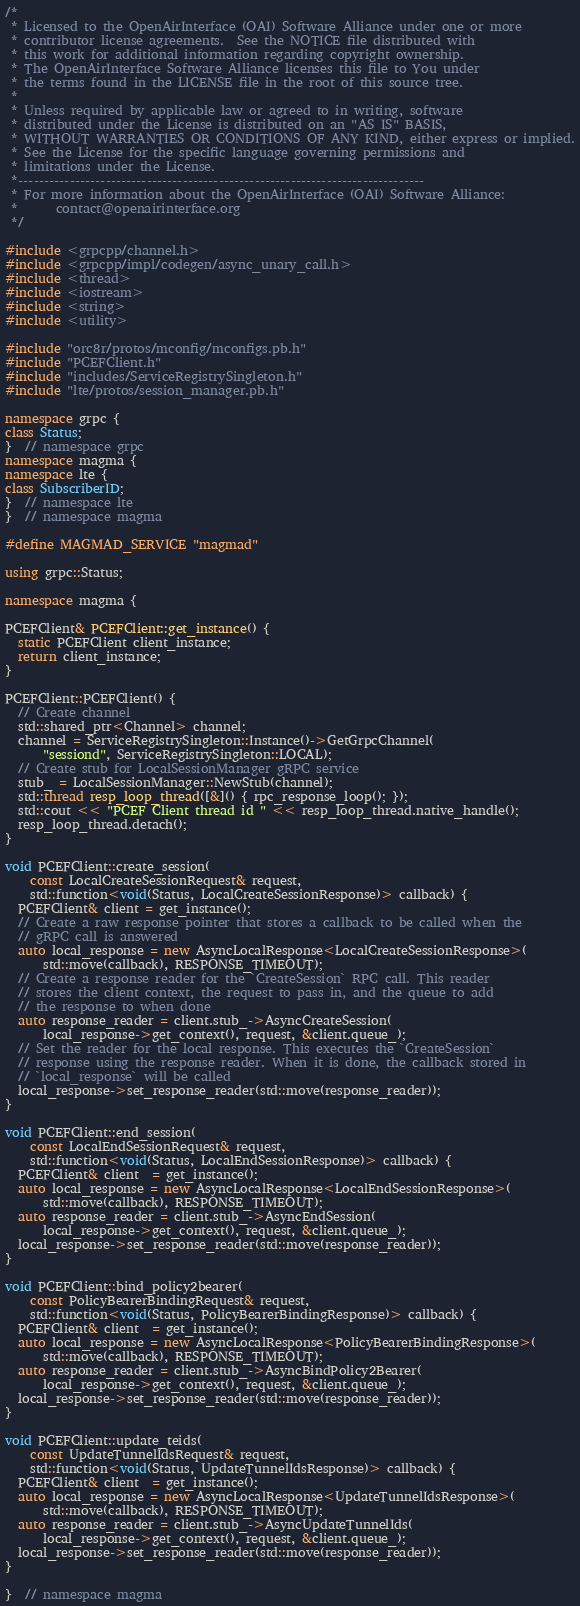<code> <loc_0><loc_0><loc_500><loc_500><_C++_>/*
 * Licensed to the OpenAirInterface (OAI) Software Alliance under one or more
 * contributor license agreements.  See the NOTICE file distributed with
 * this work for additional information regarding copyright ownership.
 * The OpenAirInterface Software Alliance licenses this file to You under
 * the terms found in the LICENSE file in the root of this source tree.
 *
 * Unless required by applicable law or agreed to in writing, software
 * distributed under the License is distributed on an "AS IS" BASIS,
 * WITHOUT WARRANTIES OR CONDITIONS OF ANY KIND, either express or implied.
 * See the License for the specific language governing permissions and
 * limitations under the License.
 *-------------------------------------------------------------------------------
 * For more information about the OpenAirInterface (OAI) Software Alliance:
 *      contact@openairinterface.org
 */

#include <grpcpp/channel.h>
#include <grpcpp/impl/codegen/async_unary_call.h>
#include <thread>
#include <iostream>
#include <string>
#include <utility>

#include "orc8r/protos/mconfig/mconfigs.pb.h"
#include "PCEFClient.h"
#include "includes/ServiceRegistrySingleton.h"
#include "lte/protos/session_manager.pb.h"

namespace grpc {
class Status;
}  // namespace grpc
namespace magma {
namespace lte {
class SubscriberID;
}  // namespace lte
}  // namespace magma

#define MAGMAD_SERVICE "magmad"

using grpc::Status;

namespace magma {

PCEFClient& PCEFClient::get_instance() {
  static PCEFClient client_instance;
  return client_instance;
}

PCEFClient::PCEFClient() {
  // Create channel
  std::shared_ptr<Channel> channel;
  channel = ServiceRegistrySingleton::Instance()->GetGrpcChannel(
      "sessiond", ServiceRegistrySingleton::LOCAL);
  // Create stub for LocalSessionManager gRPC service
  stub_ = LocalSessionManager::NewStub(channel);
  std::thread resp_loop_thread([&]() { rpc_response_loop(); });
  std::cout << "PCEF Client thread id " << resp_loop_thread.native_handle();
  resp_loop_thread.detach();
}

void PCEFClient::create_session(
    const LocalCreateSessionRequest& request,
    std::function<void(Status, LocalCreateSessionResponse)> callback) {
  PCEFClient& client = get_instance();
  // Create a raw response pointer that stores a callback to be called when the
  // gRPC call is answered
  auto local_response = new AsyncLocalResponse<LocalCreateSessionResponse>(
      std::move(callback), RESPONSE_TIMEOUT);
  // Create a response reader for the `CreateSession` RPC call. This reader
  // stores the client context, the request to pass in, and the queue to add
  // the response to when done
  auto response_reader = client.stub_->AsyncCreateSession(
      local_response->get_context(), request, &client.queue_);
  // Set the reader for the local response. This executes the `CreateSession`
  // response using the response reader. When it is done, the callback stored in
  // `local_response` will be called
  local_response->set_response_reader(std::move(response_reader));
}

void PCEFClient::end_session(
    const LocalEndSessionRequest& request,
    std::function<void(Status, LocalEndSessionResponse)> callback) {
  PCEFClient& client  = get_instance();
  auto local_response = new AsyncLocalResponse<LocalEndSessionResponse>(
      std::move(callback), RESPONSE_TIMEOUT);
  auto response_reader = client.stub_->AsyncEndSession(
      local_response->get_context(), request, &client.queue_);
  local_response->set_response_reader(std::move(response_reader));
}

void PCEFClient::bind_policy2bearer(
    const PolicyBearerBindingRequest& request,
    std::function<void(Status, PolicyBearerBindingResponse)> callback) {
  PCEFClient& client  = get_instance();
  auto local_response = new AsyncLocalResponse<PolicyBearerBindingResponse>(
      std::move(callback), RESPONSE_TIMEOUT);
  auto response_reader = client.stub_->AsyncBindPolicy2Bearer(
      local_response->get_context(), request, &client.queue_);
  local_response->set_response_reader(std::move(response_reader));
}

void PCEFClient::update_teids(
    const UpdateTunnelIdsRequest& request,
    std::function<void(Status, UpdateTunnelIdsResponse)> callback) {
  PCEFClient& client  = get_instance();
  auto local_response = new AsyncLocalResponse<UpdateTunnelIdsResponse>(
      std::move(callback), RESPONSE_TIMEOUT);
  auto response_reader = client.stub_->AsyncUpdateTunnelIds(
      local_response->get_context(), request, &client.queue_);
  local_response->set_response_reader(std::move(response_reader));
}

}  // namespace magma
</code> 